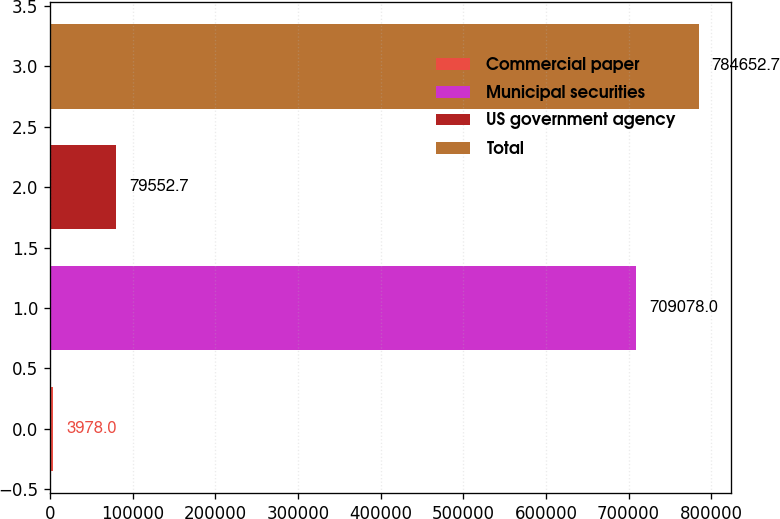Convert chart. <chart><loc_0><loc_0><loc_500><loc_500><bar_chart><fcel>Commercial paper<fcel>Municipal securities<fcel>US government agency<fcel>Total<nl><fcel>3978<fcel>709078<fcel>79552.7<fcel>784653<nl></chart> 